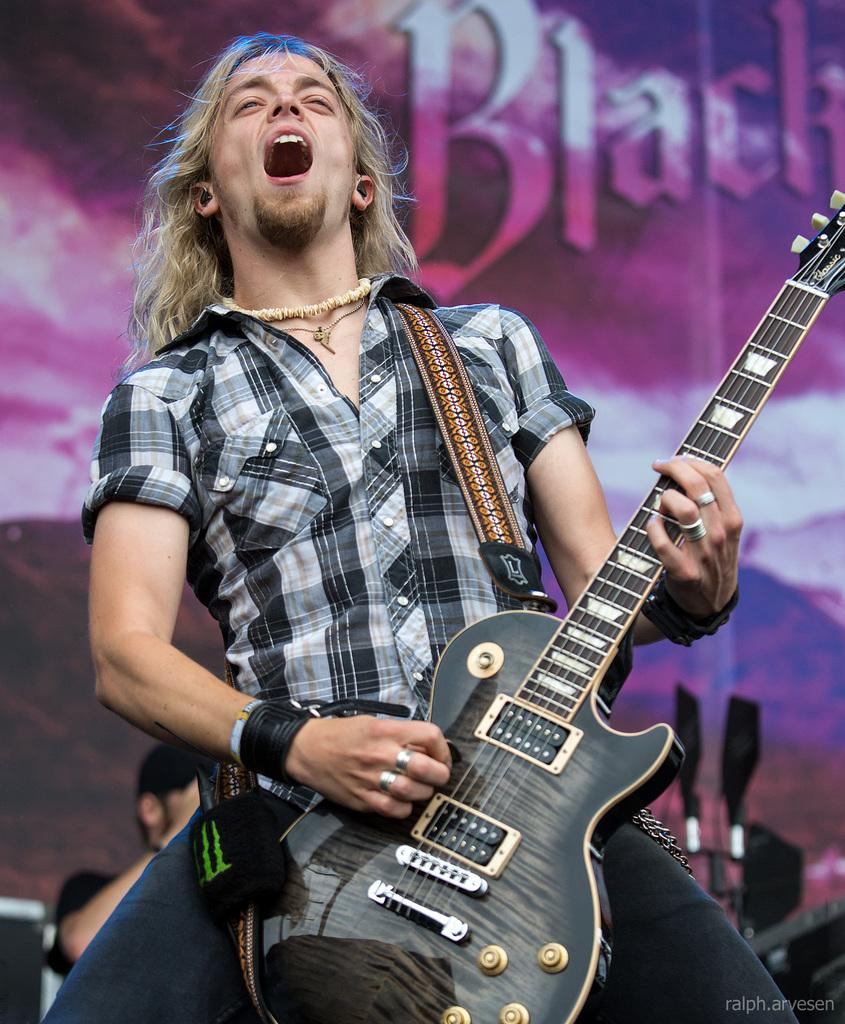What is the person in the image doing? The person is standing and singing in the image. What instrument is the person playing? The person is playing a guitar. Can you describe the other person visible in the image? There is another person visible in the image, but no specific details are provided. What can be seen in the background of the image? There is a poster in the background of the image. What color is the text on the poster? The text on the poster is black. What type of trousers is the person wearing while learning on the beam in the image? There is no beam or learning activity present in the image. The person is simply standing and singing while playing a guitar. 